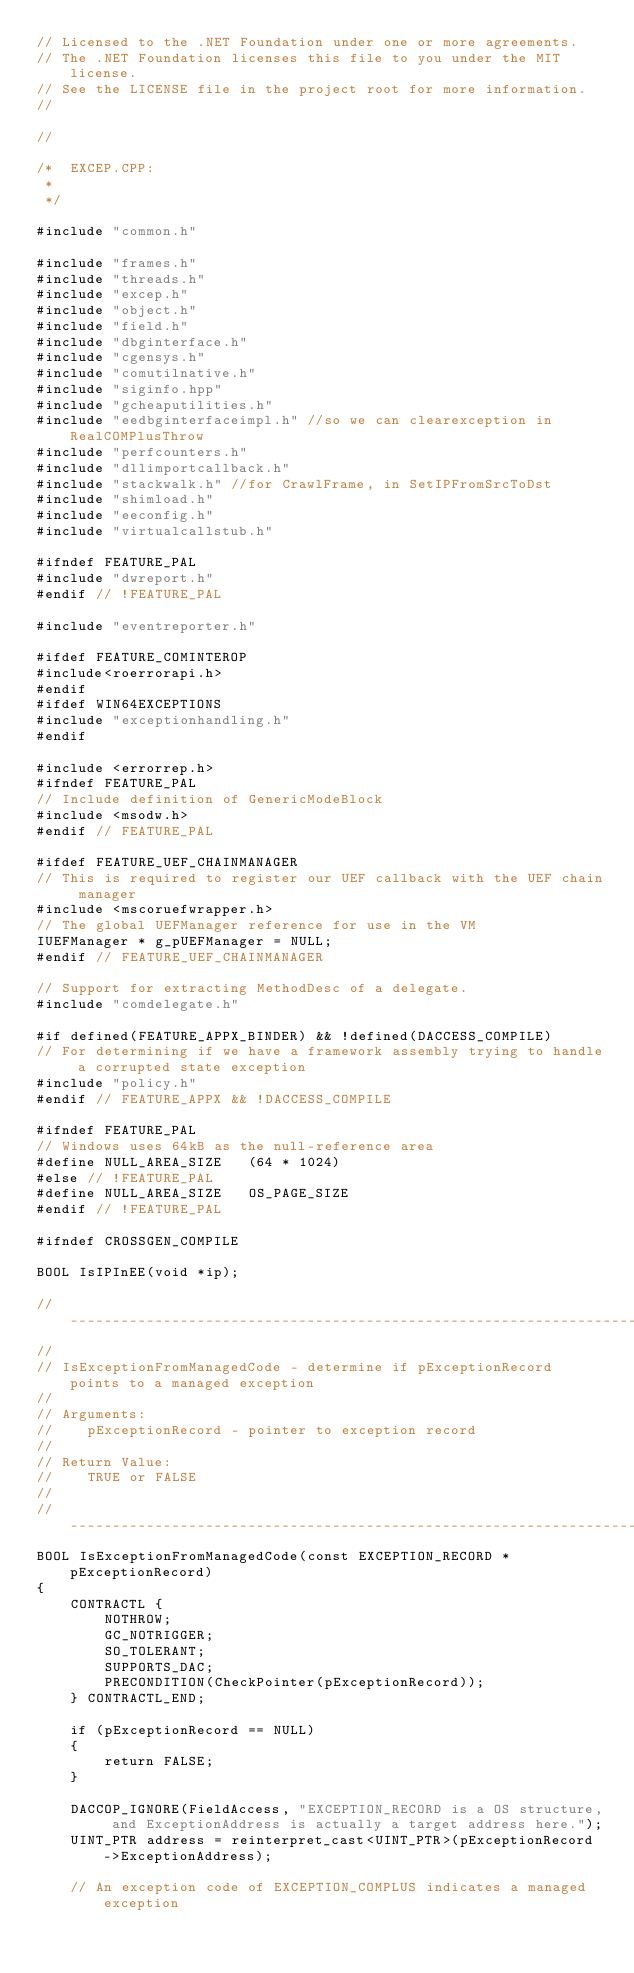Convert code to text. <code><loc_0><loc_0><loc_500><loc_500><_C++_>// Licensed to the .NET Foundation under one or more agreements.
// The .NET Foundation licenses this file to you under the MIT license.
// See the LICENSE file in the project root for more information.
//

//

/*  EXCEP.CPP:
 *
 */

#include "common.h"

#include "frames.h"
#include "threads.h"
#include "excep.h"
#include "object.h"
#include "field.h"
#include "dbginterface.h"
#include "cgensys.h"
#include "comutilnative.h"
#include "siginfo.hpp"
#include "gcheaputilities.h"
#include "eedbginterfaceimpl.h" //so we can clearexception in RealCOMPlusThrow
#include "perfcounters.h"
#include "dllimportcallback.h"
#include "stackwalk.h" //for CrawlFrame, in SetIPFromSrcToDst
#include "shimload.h"
#include "eeconfig.h"
#include "virtualcallstub.h"

#ifndef FEATURE_PAL
#include "dwreport.h"
#endif // !FEATURE_PAL

#include "eventreporter.h"

#ifdef FEATURE_COMINTEROP
#include<roerrorapi.h>
#endif
#ifdef WIN64EXCEPTIONS
#include "exceptionhandling.h"
#endif

#include <errorrep.h>
#ifndef FEATURE_PAL
// Include definition of GenericModeBlock
#include <msodw.h>
#endif // FEATURE_PAL

#ifdef FEATURE_UEF_CHAINMANAGER
// This is required to register our UEF callback with the UEF chain manager
#include <mscoruefwrapper.h>
// The global UEFManager reference for use in the VM
IUEFManager * g_pUEFManager = NULL;
#endif // FEATURE_UEF_CHAINMANAGER

// Support for extracting MethodDesc of a delegate.
#include "comdelegate.h"

#if defined(FEATURE_APPX_BINDER) && !defined(DACCESS_COMPILE)
// For determining if we have a framework assembly trying to handle a corrupted state exception
#include "policy.h"
#endif // FEATURE_APPX && !DACCESS_COMPILE

#ifndef FEATURE_PAL
// Windows uses 64kB as the null-reference area
#define NULL_AREA_SIZE   (64 * 1024)
#else // !FEATURE_PAL
#define NULL_AREA_SIZE   OS_PAGE_SIZE
#endif // !FEATURE_PAL

#ifndef CROSSGEN_COMPILE

BOOL IsIPInEE(void *ip);

//----------------------------------------------------------------------------
//
// IsExceptionFromManagedCode - determine if pExceptionRecord points to a managed exception
//
// Arguments:
//    pExceptionRecord - pointer to exception record
//
// Return Value:
//    TRUE or FALSE
//
//----------------------------------------------------------------------------
BOOL IsExceptionFromManagedCode(const EXCEPTION_RECORD * pExceptionRecord)
{
    CONTRACTL {
        NOTHROW;
        GC_NOTRIGGER;
        SO_TOLERANT;
        SUPPORTS_DAC;
        PRECONDITION(CheckPointer(pExceptionRecord));
    } CONTRACTL_END;

    if (pExceptionRecord == NULL)
    {
        return FALSE;
    }

    DACCOP_IGNORE(FieldAccess, "EXCEPTION_RECORD is a OS structure, and ExceptionAddress is actually a target address here.");
    UINT_PTR address = reinterpret_cast<UINT_PTR>(pExceptionRecord->ExceptionAddress);

    // An exception code of EXCEPTION_COMPLUS indicates a managed exception</code> 